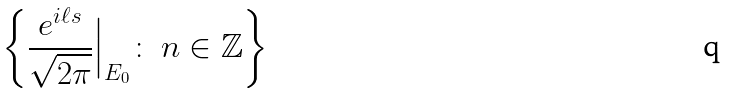<formula> <loc_0><loc_0><loc_500><loc_500>\left \{ \frac { e ^ { i \ell s } } { \sqrt { 2 \pi } } \Big | _ { E _ { 0 } } \colon \ n \in \mathbb { Z } \right \}</formula> 